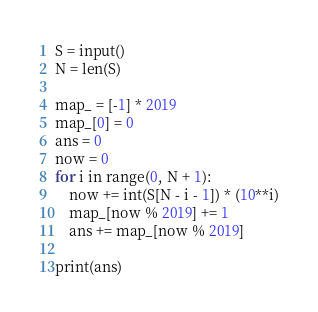<code> <loc_0><loc_0><loc_500><loc_500><_Python_>S = input()
N = len(S)

map_ = [-1] * 2019
map_[0] = 0
ans = 0
now = 0
for i in range(0, N + 1):
    now += int(S[N - i - 1]) * (10**i)
    map_[now % 2019] += 1
    ans += map_[now % 2019]

print(ans)
</code> 